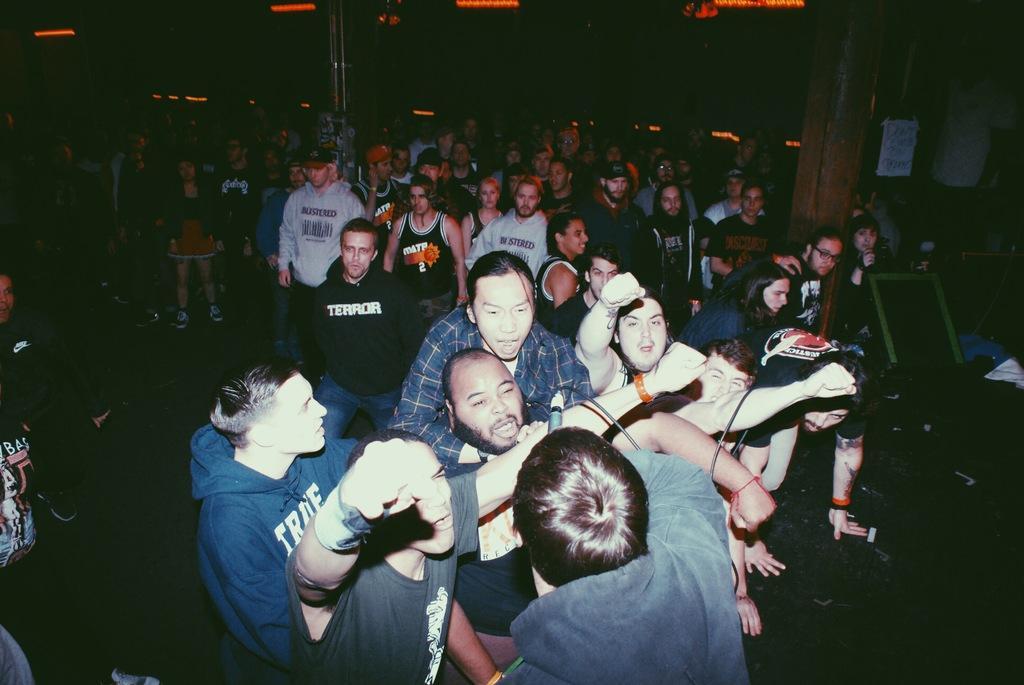How would you summarize this image in a sentence or two? In this picture there are people and we can see board, poster, pillar and few objects. In the background of the image it is dark and we can see lights. 